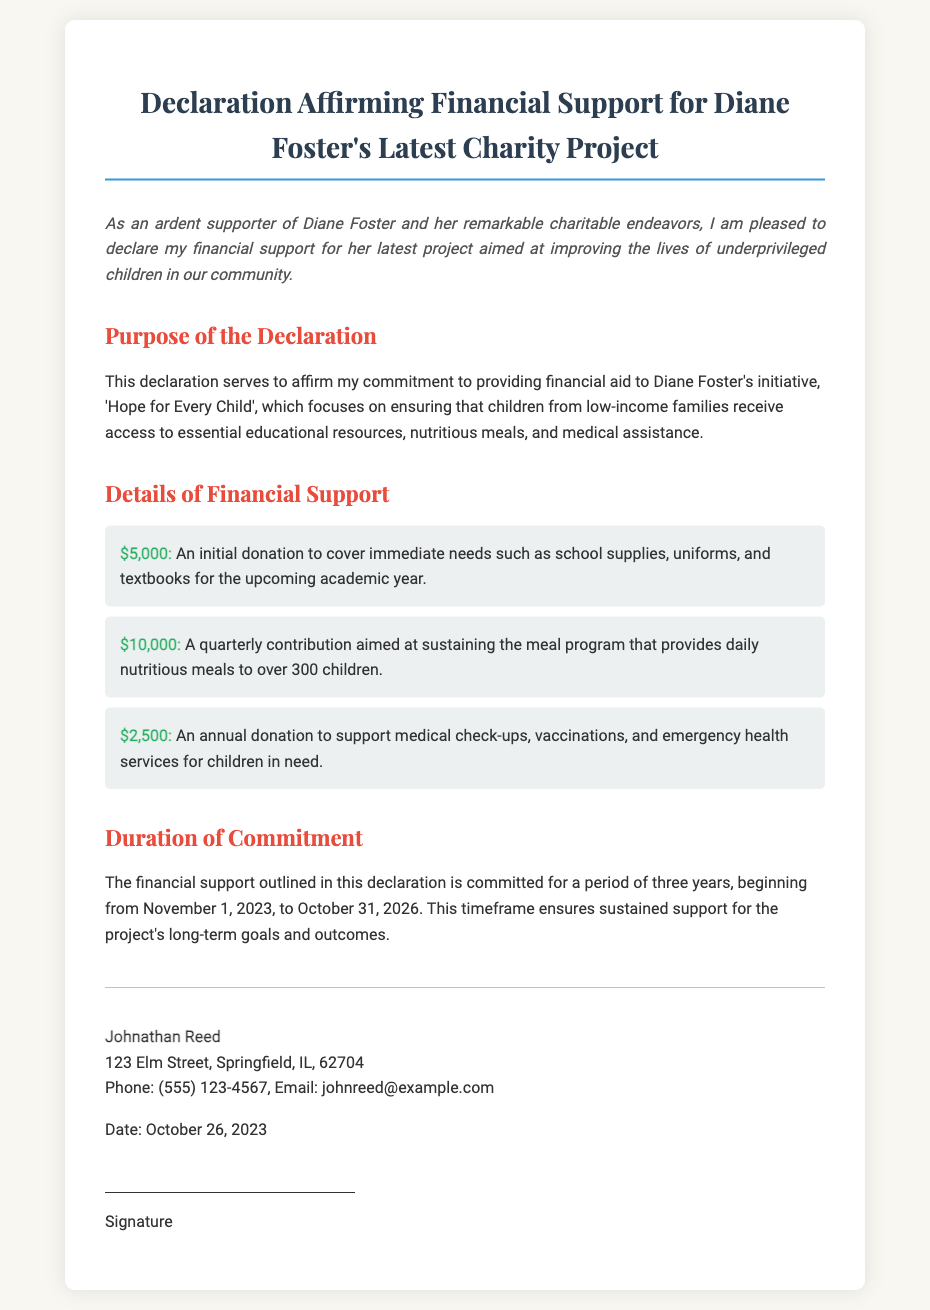What is the total amount of initial donation? The total amount of the initial donation is specified in the document as $5,000.
Answer: $5,000 Who is the signatory of the declaration? The name of the signatory as mentioned in the document is Johnathan Reed.
Answer: Johnathan Reed What is the duration of the financial support commitment? The duration of the financial support commitment is clearly stated in the document as three years.
Answer: Three years What is the total amount of quarterly contribution? The document specifies that the quarterly contribution is $10,000.
Answer: $10,000 What is the purpose of the charity project? The purpose of the charity project is articulated in the document as improving the lives of underprivileged children.
Answer: Improving the lives of underprivileged children What type of assistance will be provided to children under the program? The type of assistance includes educational resources, nutritious meals, and medical assistance.
Answer: Educational resources, nutritious meals, and medical assistance When does the financial support commitment begin? The document indicates that the financial support commitment begins on November 1, 2023.
Answer: November 1, 2023 What is included in the annual donation? The annual donation outlined in the document supports medical check-ups, vaccinations, and emergency health services.
Answer: Medical check-ups, vaccinations, and emergency health services What is the aim of the initiative 'Hope for Every Child'? The aim of the initiative is to ensure that children from low-income families receive essential support.
Answer: Essential support 